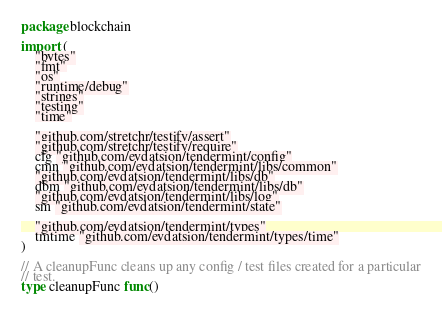<code> <loc_0><loc_0><loc_500><loc_500><_Go_>package blockchain

import (
	"bytes"
	"fmt"
	"os"
	"runtime/debug"
	"strings"
	"testing"
	"time"

	"github.com/stretchr/testify/assert"
	"github.com/stretchr/testify/require"
	cfg "github.com/evdatsion/tendermint/config"
	cmn "github.com/evdatsion/tendermint/libs/common"
	"github.com/evdatsion/tendermint/libs/db"
	dbm "github.com/evdatsion/tendermint/libs/db"
	"github.com/evdatsion/tendermint/libs/log"
	sm "github.com/evdatsion/tendermint/state"

	"github.com/evdatsion/tendermint/types"
	tmtime "github.com/evdatsion/tendermint/types/time"
)

// A cleanupFunc cleans up any config / test files created for a particular
// test.
type cleanupFunc func()
</code> 